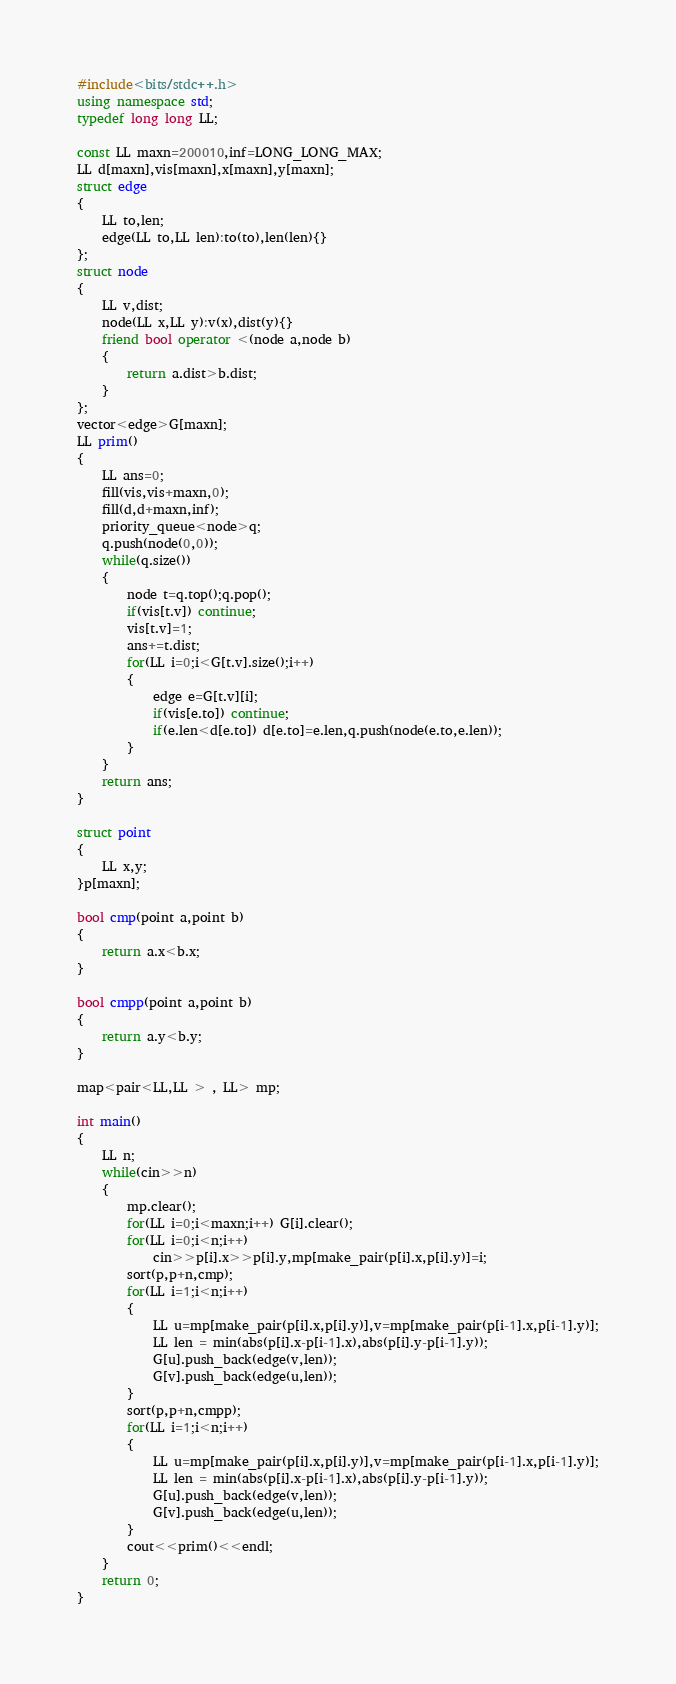<code> <loc_0><loc_0><loc_500><loc_500><_C++_>#include<bits/stdc++.h>
using namespace std;
typedef long long LL;

const LL maxn=200010,inf=LONG_LONG_MAX;
LL d[maxn],vis[maxn],x[maxn],y[maxn];
struct edge
{
    LL to,len;
    edge(LL to,LL len):to(to),len(len){}
};
struct node
{
    LL v,dist;
    node(LL x,LL y):v(x),dist(y){}
    friend bool operator <(node a,node b)
    {
        return a.dist>b.dist;
    }
};
vector<edge>G[maxn];
LL prim()
{
    LL ans=0;
    fill(vis,vis+maxn,0);
    fill(d,d+maxn,inf);
    priority_queue<node>q;
    q.push(node(0,0));
    while(q.size())
    {
        node t=q.top();q.pop();
        if(vis[t.v]) continue;
        vis[t.v]=1;
        ans+=t.dist;
        for(LL i=0;i<G[t.v].size();i++)
        {
            edge e=G[t.v][i];
            if(vis[e.to]) continue;
            if(e.len<d[e.to]) d[e.to]=e.len,q.push(node(e.to,e.len));
        }
    }
    return ans;
}

struct point
{
    LL x,y;
}p[maxn];

bool cmp(point a,point b)
{
    return a.x<b.x;
}

bool cmpp(point a,point b)
{
    return a.y<b.y;
}

map<pair<LL,LL > , LL> mp;

int main()
{
    LL n;
    while(cin>>n)
    {
        mp.clear();
        for(LL i=0;i<maxn;i++) G[i].clear();
        for(LL i=0;i<n;i++)
            cin>>p[i].x>>p[i].y,mp[make_pair(p[i].x,p[i].y)]=i;
        sort(p,p+n,cmp);
        for(LL i=1;i<n;i++)
        {
            LL u=mp[make_pair(p[i].x,p[i].y)],v=mp[make_pair(p[i-1].x,p[i-1].y)];
            LL len = min(abs(p[i].x-p[i-1].x),abs(p[i].y-p[i-1].y));
            G[u].push_back(edge(v,len));
            G[v].push_back(edge(u,len));
        }
        sort(p,p+n,cmpp);
        for(LL i=1;i<n;i++)
        {
            LL u=mp[make_pair(p[i].x,p[i].y)],v=mp[make_pair(p[i-1].x,p[i-1].y)];
            LL len = min(abs(p[i].x-p[i-1].x),abs(p[i].y-p[i-1].y));
            G[u].push_back(edge(v,len));
            G[v].push_back(edge(u,len));
        }
        cout<<prim()<<endl;
    }
    return 0;
}
</code> 